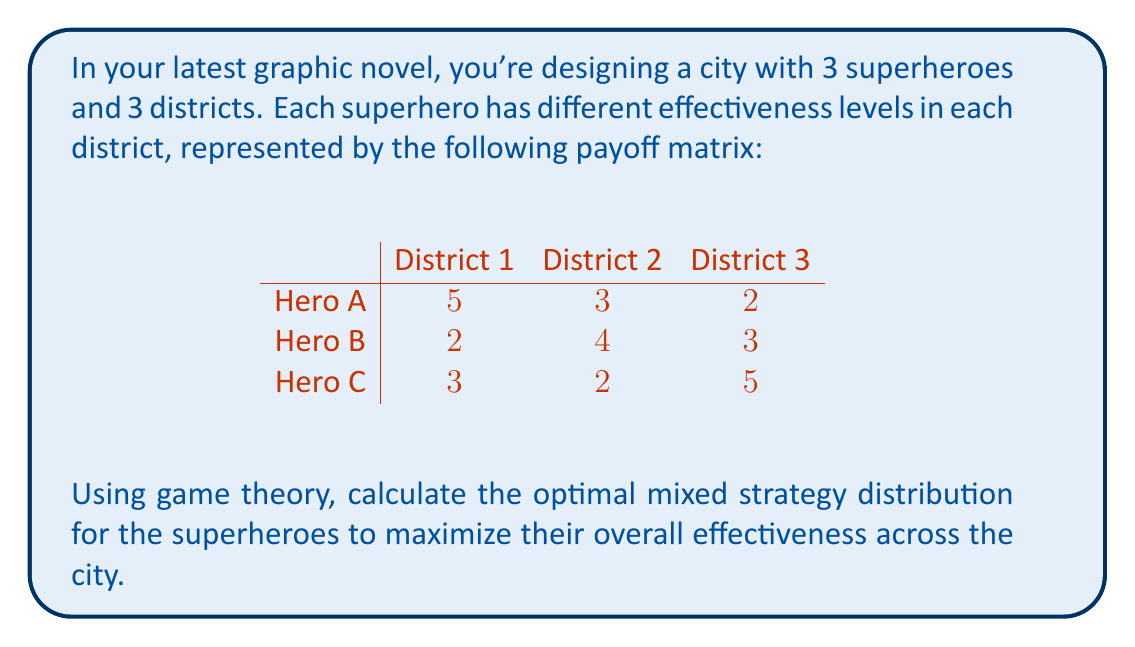Can you solve this math problem? To solve this problem, we'll use the concept of mixed strategy Nash equilibrium in game theory. Here's a step-by-step approach:

1) First, we need to set up the linear equations for each strategy to have equal expected payoff:

   Let $x$, $y$, and $z$ be the probabilities of choosing District 1, 2, and 3 respectively.

   For Hero A: $5x + 3y + 2z = v$
   For Hero B: $2x + 4y + 3z = v$
   For Hero C: $3x + 2y + 5z = v$

   Where $v$ is the expected payoff.

2) We also know that the probabilities must sum to 1:

   $x + y + z = 1$

3) Now we have a system of 4 equations with 4 unknowns. We can solve this using substitution or matrix methods. Let's use substitution:

4) From the first three equations:
   
   $5x + 3y + 2z = 2x + 4y + 3z$
   $5x + 3y + 2z = 3x + 2y + 5z$

5) Simplifying:

   $3x - y - z = 0$
   $2x + y - 3z = 0$

6) Using these along with $x + y + z = 1$, we can solve:

   From (1): $y = 3x - z$
   Substituting into (2): $2x + (3x - z) - 3z = 0$
                          $5x - 4z = 0$
                          $z = \frac{5x}{4}$

   Substituting both into $x + y + z = 1$:
   
   $x + (3x - \frac{5x}{4}) + \frac{5x}{4} = 1$
   $4x = 1$
   $x = \frac{1}{4}$

7) Now we can find $y$ and $z$:

   $z = \frac{5}{16}$
   $y = 1 - x - z = 1 - \frac{1}{4} - \frac{5}{16} = \frac{7}{16}$

8) Therefore, the optimal mixed strategy is:

   District 1: $\frac{1}{4}$
   District 2: $\frac{7}{16}$
   District 3: $\frac{5}{16}$

This distribution ensures that no superhero can improve their effectiveness by changing their strategy unilaterally.
Answer: $(\frac{1}{4}, \frac{7}{16}, \frac{5}{16})$ 